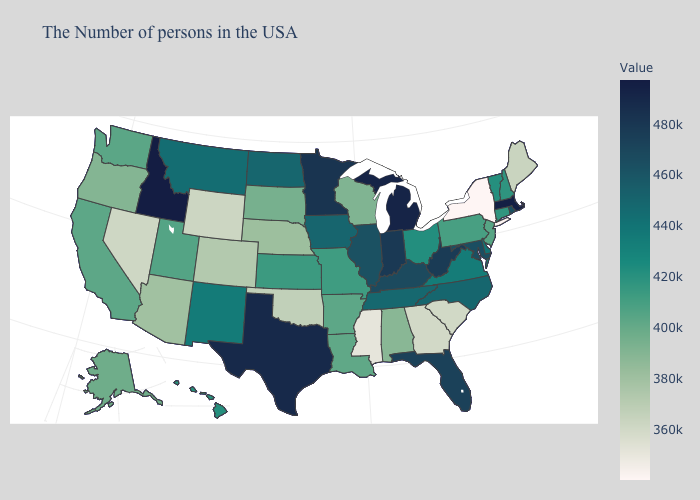Does the map have missing data?
Answer briefly. No. Does Idaho have the lowest value in the West?
Be succinct. No. Which states hav the highest value in the MidWest?
Be succinct. Michigan. Does Nevada have the lowest value in the West?
Answer briefly. Yes. 